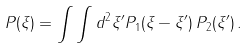<formula> <loc_0><loc_0><loc_500><loc_500>P ( \xi ) = \int \int d ^ { 2 } \xi ^ { \prime } P _ { 1 } ( \xi - \xi ^ { \prime } ) \, P _ { 2 } ( \xi ^ { \prime } ) \, .</formula> 